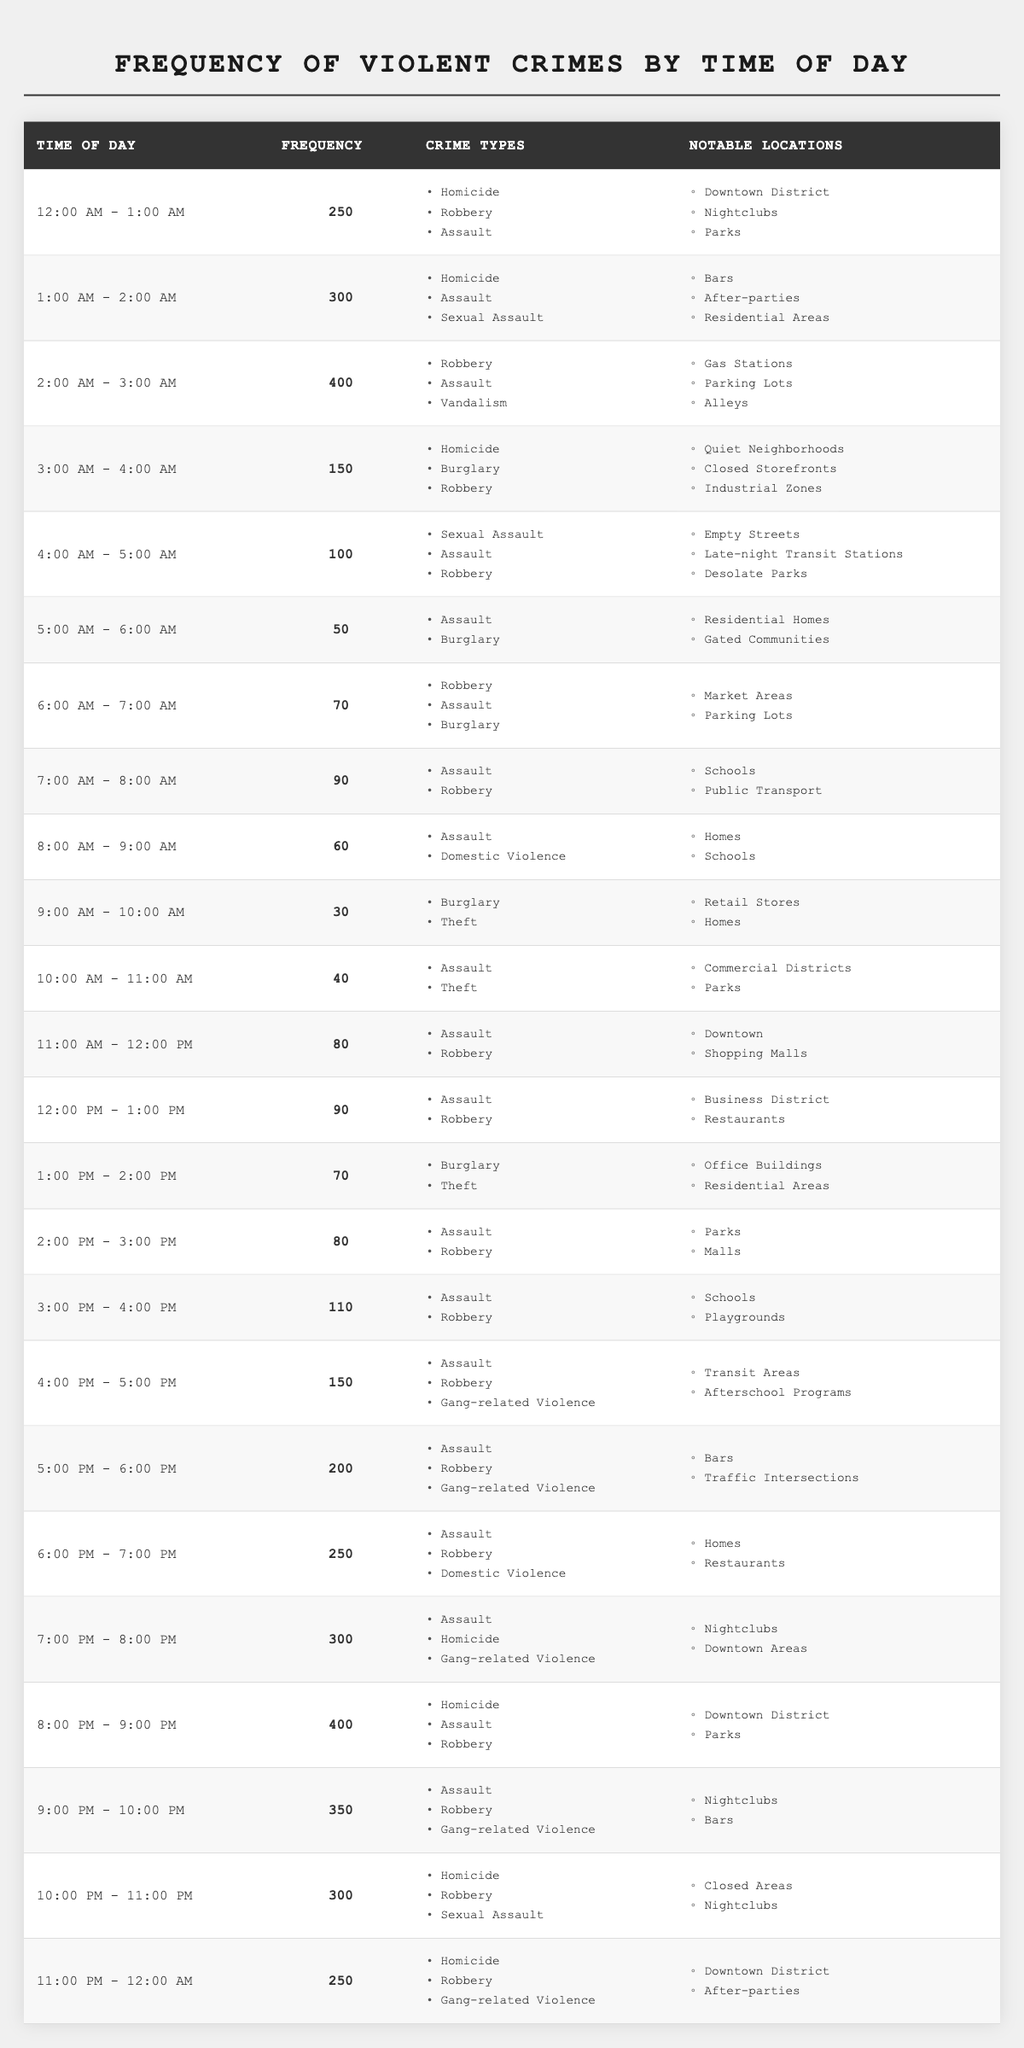What time period has the highest frequency of violent crimes? The highest frequency in the table is listed for the time period of "8:00 PM - 9:00 PM" with a frequency of 400.
Answer: 8:00 PM - 9:00 PM Which types of crimes are most frequently committed during the time period of 4:00 PM - 5:00 PM? During this period, the crimes listed are "Assault," "Robbery," and "Gang-related Violence."
Answer: Assault, Robbery, Gang-related Violence How does the frequency of violent crimes between 5:00 PM - 6:00 PM compare to that between 1:00 AM - 2:00 AM? The frequency for 5:00 PM - 6:00 PM is 200, while for 1:00 AM - 2:00 AM it is 300. Therefore, there are 100 more crimes during the earlier period.
Answer: 100 more crimes at 1:00 AM - 2:00 AM Are there more violent crimes during the late-night hours (12:00 AM - 6:00 AM) or the evening hours (6:00 PM - 12:00 AM)? The sum of violent crimes from 12:00 AM - 6:00 AM is 1,320, and from 6:00 PM - 12:00 AM is 1,550. Thus, there are more crimes during evening hours.
Answer: Evening hours have more crimes What notable locations are highlighted for violent crimes occurring between 7:00 PM - 8:00 PM? Notable locations during this time include "Nightclubs" and "Downtown Areas."
Answer: Nightclubs, Downtown Areas If you combine the frequencies of the time periods of 3:00 AM - 4:00 AM and 4:00 AM - 5:00 AM, what is the total? The frequency for 3:00 AM - 4:00 AM is 150 and for 4:00 AM - 5:00 AM is 100. Adding these gives 150 + 100 = 250.
Answer: 250 Is it true that the crime frequency during lunchtime (12:00 PM - 1:00 PM) is higher than during breakfast hours (6:00 AM - 7:00 AM)? Yes, the frequency at lunch is 90 while at breakfast it is 70, so the lunchtime frequency is higher.
Answer: Yes Which hour had the second highest number of violent crimes and what is the frequency? The time period "7:00 PM - 8:00 PM" has the second highest frequency of 300.
Answer: 300 How many types of crimes are listed for the time slot "10:00 AM - 11:00 AM"? There are two types of crimes listed: "Assault" and "Theft."
Answer: Two types of crimes What time period has the highest frequency of "Homicide" crimes? The time period "8:00 PM - 9:00 PM" has "Homicide" listed and also has the highest frequency overall of 400.
Answer: 8:00 PM - 9:00 PM In which time period does "Domestic Violence" appear, and what is its associated frequency? "Domestic Violence" appears during "6:00 PM - 7:00 PM," with a frequency of 250.
Answer: 6:00 PM - 7:00 PM, frequency 250 